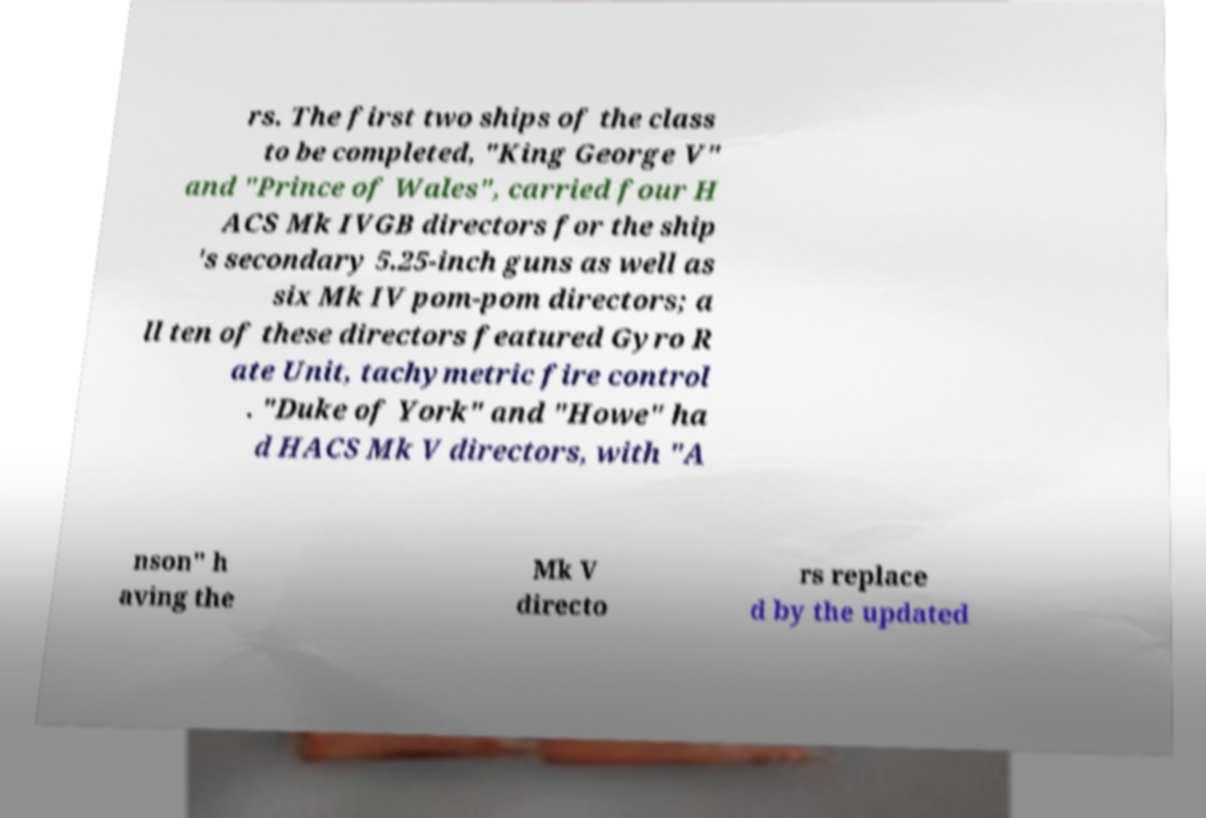I need the written content from this picture converted into text. Can you do that? rs. The first two ships of the class to be completed, "King George V" and "Prince of Wales", carried four H ACS Mk IVGB directors for the ship 's secondary 5.25-inch guns as well as six Mk IV pom-pom directors; a ll ten of these directors featured Gyro R ate Unit, tachymetric fire control . "Duke of York" and "Howe" ha d HACS Mk V directors, with "A nson" h aving the Mk V directo rs replace d by the updated 